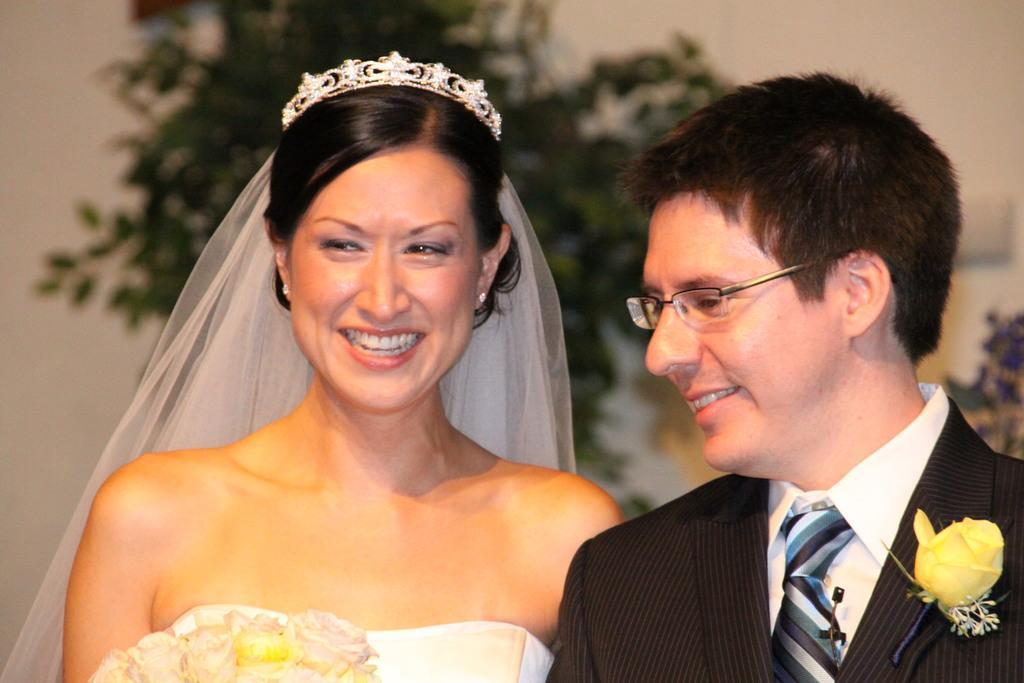Could you give a brief overview of what you see in this image? In the middle of the image two persons are standing and smiling. Behind them we can see some plants and wall. 